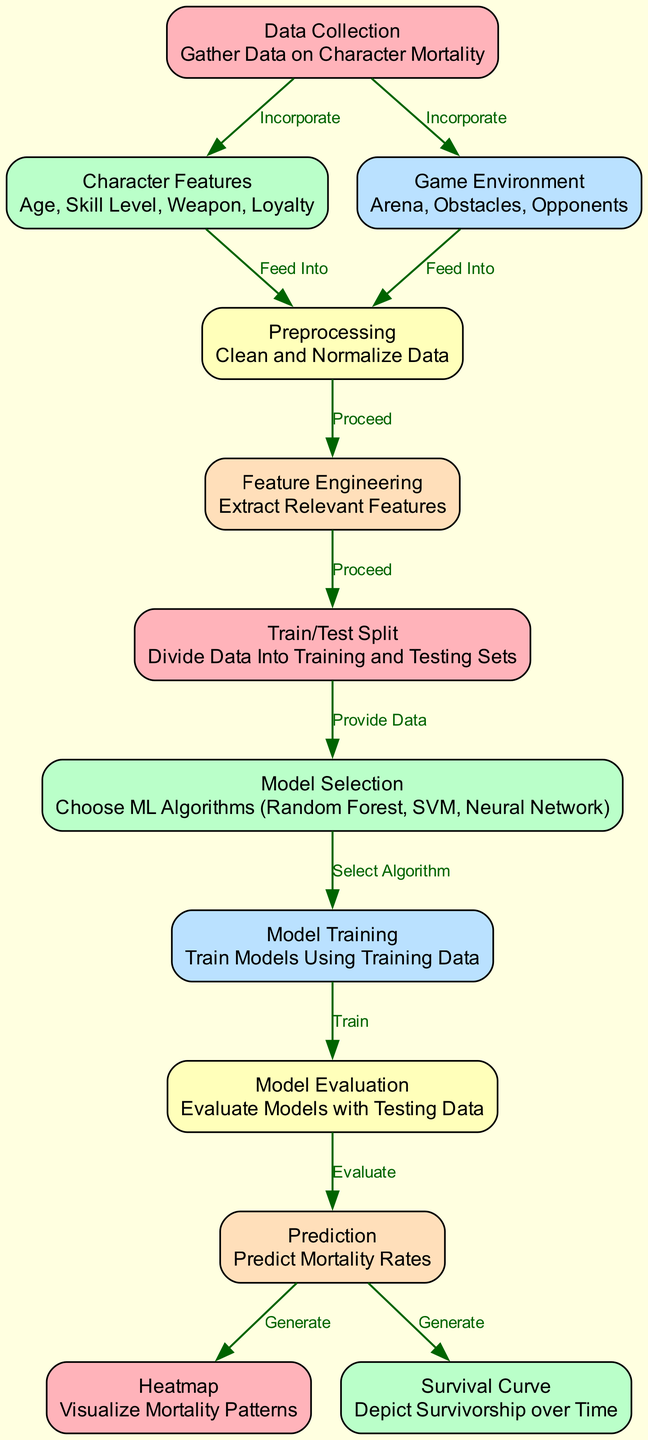What's the total number of nodes in the diagram? By counting the individual components labeled as nodes in the diagram, which are defined in the data section, we find there are 12 distinct nodes: Data Collection, Character Features, Game Environment, Preprocessing, Feature Engineering, Train/Test Split, Model Selection, Model Training, Model Evaluation, Prediction, Heatmap, and Survival Curve.
Answer: 12 What is the label of the node that follows "Feature Engineering"? According to the directed flow of the diagram, the node immediately following Feature Engineering is the Train/Test Split node, which indicates that after feature engineering, the next step is to divide the data into training and testing sets.
Answer: Train/Test Split How many edges are present in the diagram? By analyzing the edges defined in the data section, we can count each connection that links nodes. There are 11 edges represented, indicating the relationships and flow of information between nodes in the diagram.
Answer: 11 Which node generates the Heatmap? In the flow of the diagram, the Prediction node leads directly to the Heatmap node, indicating that the predictions made are used to create the heatmap visualizing mortality patterns in characters from morbid games.
Answer: Prediction In which stage are the relevant features extracted? The diagram shows that after preprocessing the data, the next step is Feature Engineering, where relevant features are extracted for further processing in the machine learning pipeline.
Answer: Feature Engineering What is the final output of the diagram? The final outcomes of the diagram, as indicated by the flow, are the Heatmap and Survival Curve, which are visual depictions generated from the predictions made in the modeling process, reflecting mortality patterns and survivorship over time.
Answer: Heatmap and Survival Curve What relationship does "Model Training" have with "Model Evaluation"? The flow indicates that after the Model Training node is completed, it leads to the Model Evaluation node, which suggests that the trained models are then evaluated using testing data to determine their effectiveness.
Answer: Train Which processes feed into the "Preprocessing" step? The nodes that feed into Preprocessing, as shown in the diagram, are Character Features and Game Environment. These nodes provide the necessary data inputs that are cleaned and normalized in the preprocessing stage.
Answer: Character Features and Game Environment What is the purpose of the "Survival Curve"? The purpose of the Survival Curve node, as depicted in the diagram, is to depict the survivorship of characters over time, offering insight into how different factors affect their longevity within the games.
Answer: Depict Survivorship over Time 